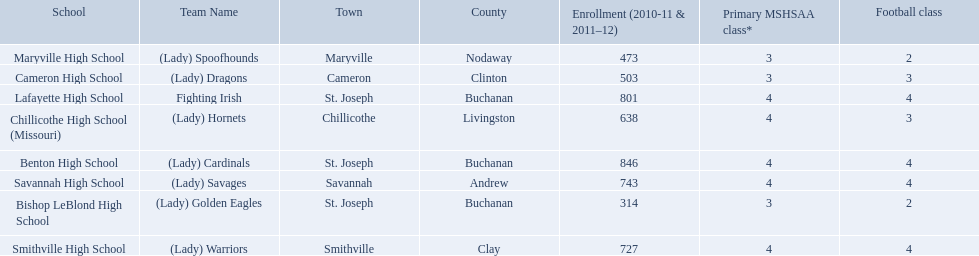What are the three schools in the town of st. joseph? St. Joseph, St. Joseph, St. Joseph. Of the three schools in st. joseph which school's team name does not depict a type of animal? Lafayette High School. 